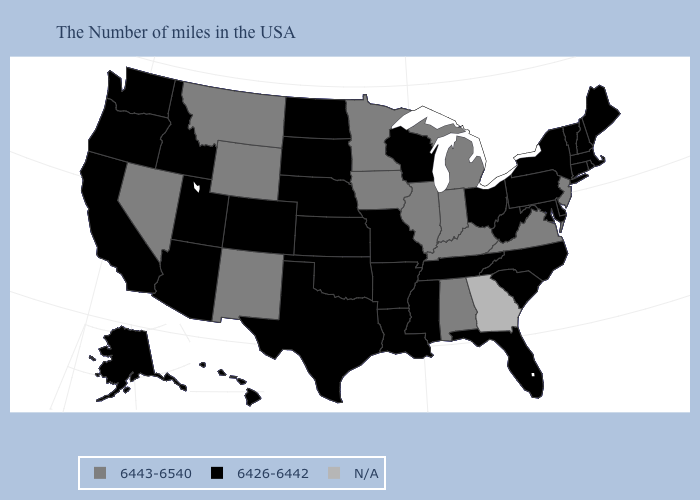What is the value of Georgia?
Concise answer only. N/A. Name the states that have a value in the range 6426-6442?
Quick response, please. Maine, Massachusetts, Rhode Island, New Hampshire, Vermont, Connecticut, New York, Delaware, Maryland, Pennsylvania, North Carolina, South Carolina, West Virginia, Ohio, Florida, Tennessee, Wisconsin, Mississippi, Louisiana, Missouri, Arkansas, Kansas, Nebraska, Oklahoma, Texas, South Dakota, North Dakota, Colorado, Utah, Arizona, Idaho, California, Washington, Oregon, Alaska, Hawaii. Name the states that have a value in the range 6426-6442?
Write a very short answer. Maine, Massachusetts, Rhode Island, New Hampshire, Vermont, Connecticut, New York, Delaware, Maryland, Pennsylvania, North Carolina, South Carolina, West Virginia, Ohio, Florida, Tennessee, Wisconsin, Mississippi, Louisiana, Missouri, Arkansas, Kansas, Nebraska, Oklahoma, Texas, South Dakota, North Dakota, Colorado, Utah, Arizona, Idaho, California, Washington, Oregon, Alaska, Hawaii. Which states have the highest value in the USA?
Short answer required. New Jersey, Virginia, Michigan, Kentucky, Indiana, Alabama, Illinois, Minnesota, Iowa, Wyoming, New Mexico, Montana, Nevada. Does New Jersey have the lowest value in the Northeast?
Give a very brief answer. No. What is the value of New Jersey?
Be succinct. 6443-6540. What is the highest value in the Northeast ?
Keep it brief. 6443-6540. What is the lowest value in the USA?
Answer briefly. 6426-6442. Name the states that have a value in the range 6426-6442?
Quick response, please. Maine, Massachusetts, Rhode Island, New Hampshire, Vermont, Connecticut, New York, Delaware, Maryland, Pennsylvania, North Carolina, South Carolina, West Virginia, Ohio, Florida, Tennessee, Wisconsin, Mississippi, Louisiana, Missouri, Arkansas, Kansas, Nebraska, Oklahoma, Texas, South Dakota, North Dakota, Colorado, Utah, Arizona, Idaho, California, Washington, Oregon, Alaska, Hawaii. What is the lowest value in the MidWest?
Keep it brief. 6426-6442. Does Illinois have the lowest value in the MidWest?
Quick response, please. No. What is the value of Wisconsin?
Keep it brief. 6426-6442. What is the value of Alabama?
Be succinct. 6443-6540. 